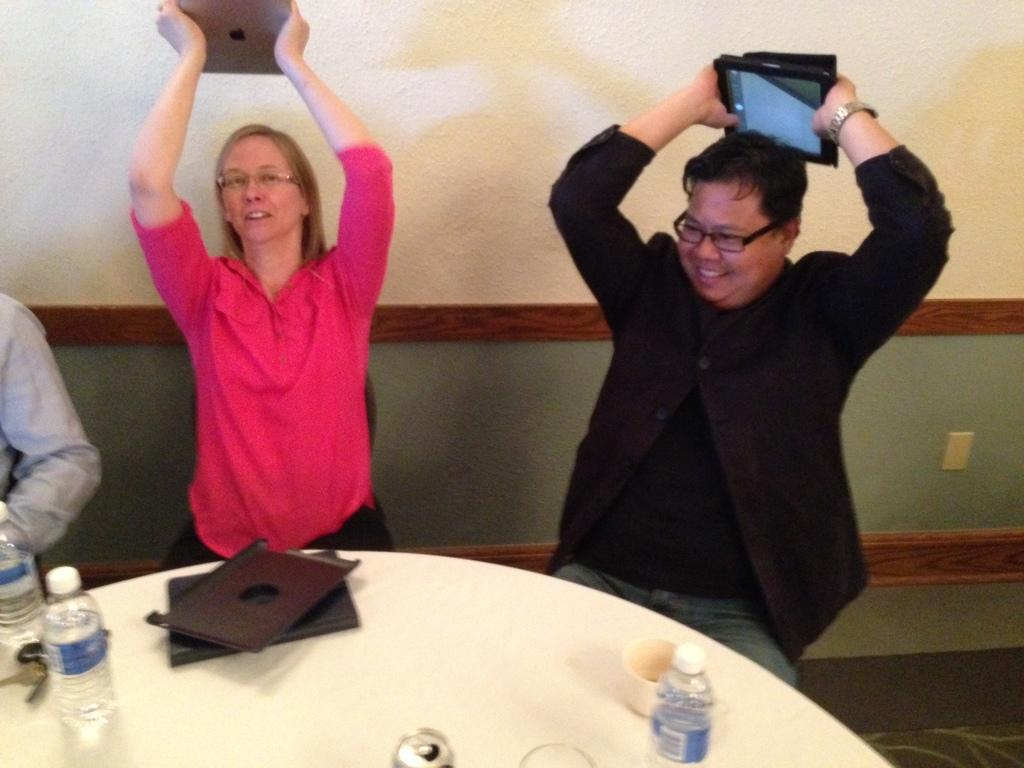How many people are in the image? There are two persons in the image. What are the persons doing in the image? The persons are sitting on a chair and holding a laptop. What is present on the table in the image? There are bottles, a file, and a cup on the table. What type of letter is being written by the cloud in the image? There is no cloud present in the image, and therefore no such activity can be observed. 